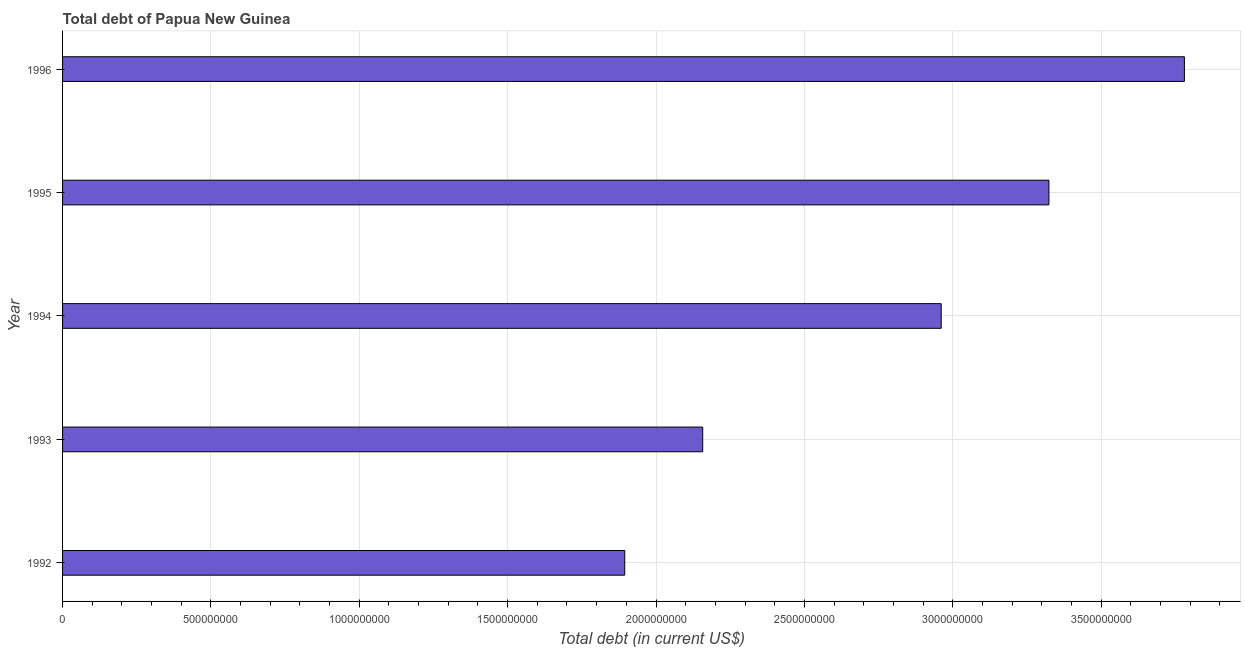Does the graph contain grids?
Your answer should be very brief. Yes. What is the title of the graph?
Your answer should be very brief. Total debt of Papua New Guinea. What is the label or title of the X-axis?
Your response must be concise. Total debt (in current US$). What is the total debt in 1993?
Ensure brevity in your answer.  2.16e+09. Across all years, what is the maximum total debt?
Your answer should be compact. 3.78e+09. Across all years, what is the minimum total debt?
Keep it short and to the point. 1.89e+09. In which year was the total debt minimum?
Offer a terse response. 1992. What is the sum of the total debt?
Provide a succinct answer. 1.41e+1. What is the difference between the total debt in 1995 and 1996?
Make the answer very short. -4.57e+08. What is the average total debt per year?
Give a very brief answer. 2.82e+09. What is the median total debt?
Offer a terse response. 2.96e+09. What is the ratio of the total debt in 1995 to that in 1996?
Keep it short and to the point. 0.88. Is the difference between the total debt in 1992 and 1995 greater than the difference between any two years?
Offer a terse response. No. What is the difference between the highest and the second highest total debt?
Your answer should be very brief. 4.57e+08. What is the difference between the highest and the lowest total debt?
Your answer should be compact. 1.89e+09. How many years are there in the graph?
Keep it short and to the point. 5. What is the difference between two consecutive major ticks on the X-axis?
Provide a short and direct response. 5.00e+08. Are the values on the major ticks of X-axis written in scientific E-notation?
Your answer should be compact. No. What is the Total debt (in current US$) of 1992?
Give a very brief answer. 1.89e+09. What is the Total debt (in current US$) in 1993?
Provide a short and direct response. 2.16e+09. What is the Total debt (in current US$) of 1994?
Offer a terse response. 2.96e+09. What is the Total debt (in current US$) of 1995?
Your answer should be very brief. 3.32e+09. What is the Total debt (in current US$) in 1996?
Give a very brief answer. 3.78e+09. What is the difference between the Total debt (in current US$) in 1992 and 1993?
Offer a terse response. -2.63e+08. What is the difference between the Total debt (in current US$) in 1992 and 1994?
Provide a short and direct response. -1.07e+09. What is the difference between the Total debt (in current US$) in 1992 and 1995?
Provide a short and direct response. -1.43e+09. What is the difference between the Total debt (in current US$) in 1992 and 1996?
Your response must be concise. -1.89e+09. What is the difference between the Total debt (in current US$) in 1993 and 1994?
Provide a succinct answer. -8.04e+08. What is the difference between the Total debt (in current US$) in 1993 and 1995?
Give a very brief answer. -1.17e+09. What is the difference between the Total debt (in current US$) in 1993 and 1996?
Your answer should be compact. -1.62e+09. What is the difference between the Total debt (in current US$) in 1994 and 1995?
Provide a succinct answer. -3.63e+08. What is the difference between the Total debt (in current US$) in 1994 and 1996?
Your answer should be compact. -8.20e+08. What is the difference between the Total debt (in current US$) in 1995 and 1996?
Provide a succinct answer. -4.57e+08. What is the ratio of the Total debt (in current US$) in 1992 to that in 1993?
Your response must be concise. 0.88. What is the ratio of the Total debt (in current US$) in 1992 to that in 1994?
Make the answer very short. 0.64. What is the ratio of the Total debt (in current US$) in 1992 to that in 1995?
Give a very brief answer. 0.57. What is the ratio of the Total debt (in current US$) in 1992 to that in 1996?
Your answer should be compact. 0.5. What is the ratio of the Total debt (in current US$) in 1993 to that in 1994?
Ensure brevity in your answer.  0.73. What is the ratio of the Total debt (in current US$) in 1993 to that in 1995?
Give a very brief answer. 0.65. What is the ratio of the Total debt (in current US$) in 1993 to that in 1996?
Make the answer very short. 0.57. What is the ratio of the Total debt (in current US$) in 1994 to that in 1995?
Ensure brevity in your answer.  0.89. What is the ratio of the Total debt (in current US$) in 1994 to that in 1996?
Make the answer very short. 0.78. What is the ratio of the Total debt (in current US$) in 1995 to that in 1996?
Make the answer very short. 0.88. 